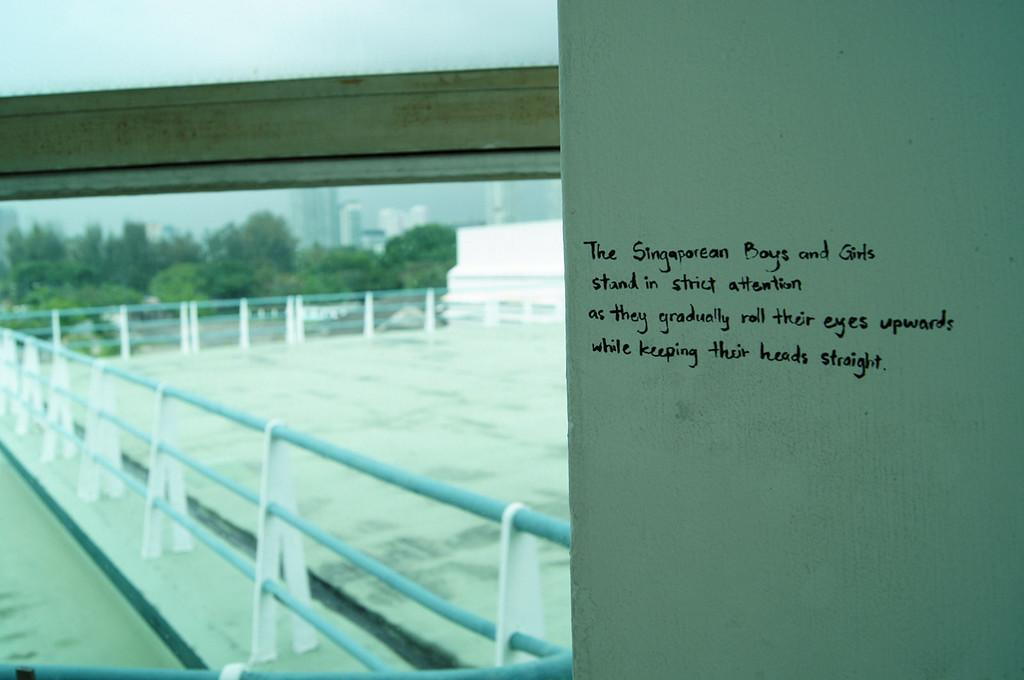What is the surface on which the text is written in the image? The text is written on a white platform in the image. What type of barrier can be seen in the image? There is a fence in the image. What can be seen in the distance in the image? There are trees, buildings, and the sky visible in the background of the image. Who is talking to the letter in the image? There is no letter or person talking to a letter present in the image. What type of property is being discussed in the image? There is no discussion of property in the image; it features text on a white platform, a fence, and a background with trees, buildings, and the sky. 